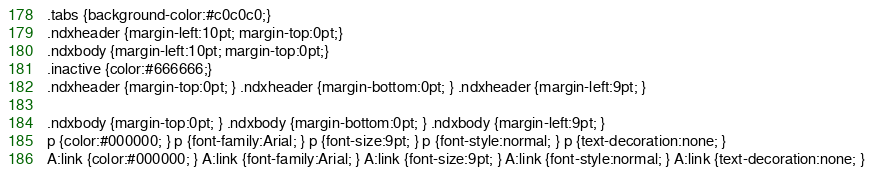<code> <loc_0><loc_0><loc_500><loc_500><_HTML_>
.tabs {background-color:#c0c0c0;}
.ndxheader {margin-left:10pt; margin-top:0pt;}
.ndxbody {margin-left:10pt; margin-top:0pt;}
.inactive {color:#666666;}
.ndxheader {margin-top:0pt; } .ndxheader {margin-bottom:0pt; } .ndxheader {margin-left:9pt; } 

.ndxbody {margin-top:0pt; } .ndxbody {margin-bottom:0pt; } .ndxbody {margin-left:9pt; } 
p {color:#000000; } p {font-family:Arial; } p {font-size:9pt; } p {font-style:normal; } p {text-decoration:none; } 
A:link {color:#000000; } A:link {font-family:Arial; } A:link {font-size:9pt; } A:link {font-style:normal; } A:link {text-decoration:none; } </code> 